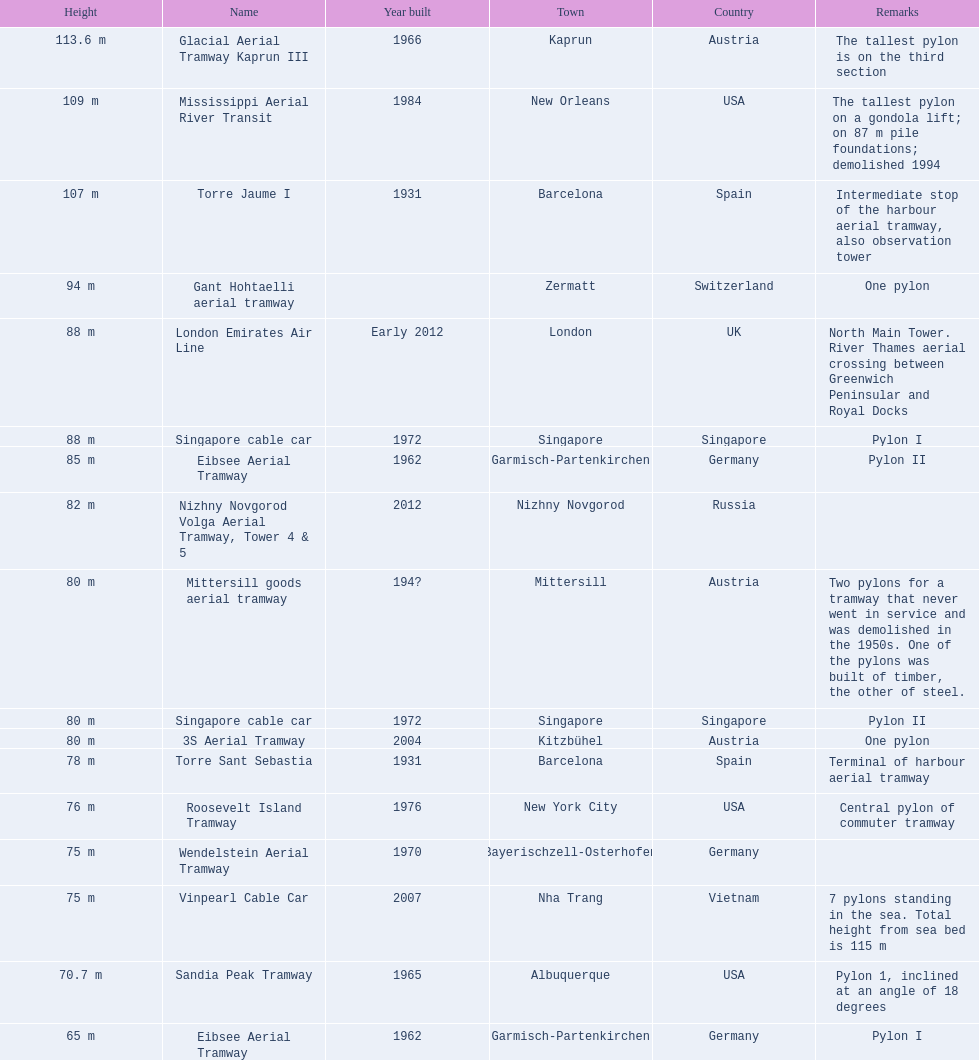How many pylons are at least 80 meters tall? 11. 